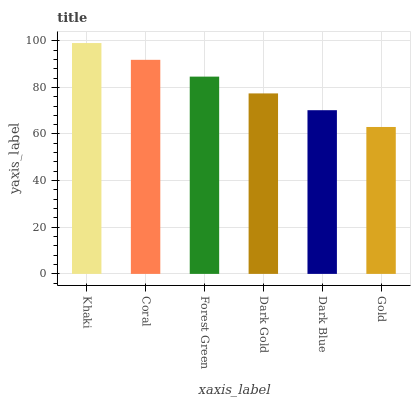Is Gold the minimum?
Answer yes or no. Yes. Is Khaki the maximum?
Answer yes or no. Yes. Is Coral the minimum?
Answer yes or no. No. Is Coral the maximum?
Answer yes or no. No. Is Khaki greater than Coral?
Answer yes or no. Yes. Is Coral less than Khaki?
Answer yes or no. Yes. Is Coral greater than Khaki?
Answer yes or no. No. Is Khaki less than Coral?
Answer yes or no. No. Is Forest Green the high median?
Answer yes or no. Yes. Is Dark Gold the low median?
Answer yes or no. Yes. Is Dark Blue the high median?
Answer yes or no. No. Is Dark Blue the low median?
Answer yes or no. No. 